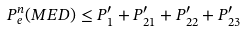<formula> <loc_0><loc_0><loc_500><loc_500>P _ { e } ^ { n } ( M E D ) \leq P _ { 1 } ^ { \prime } + P _ { 2 1 } ^ { \prime } + P _ { 2 2 } ^ { \prime } + P _ { 2 3 } ^ { \prime }</formula> 